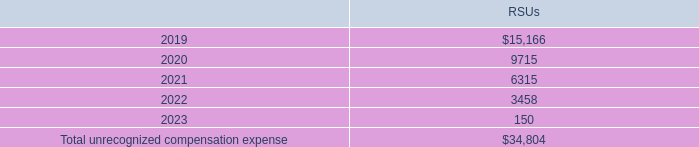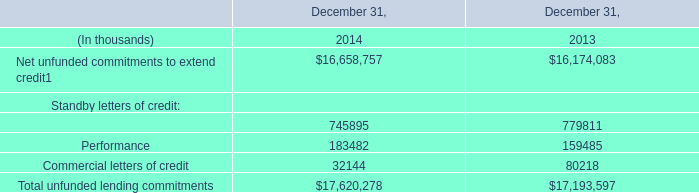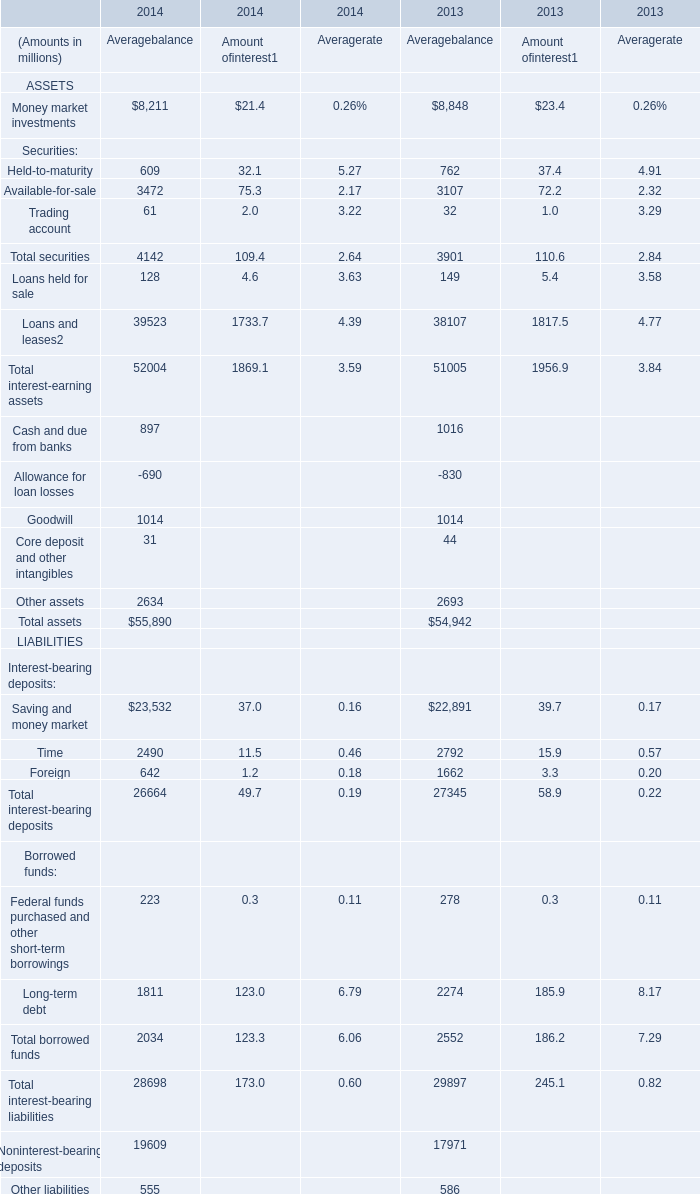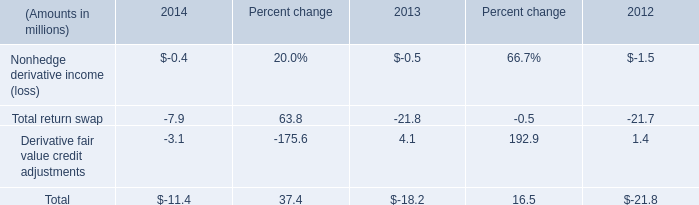What's the average of the Total return swap for amount in the years where Financial for Standby letters of credit is positive? (in million) 
Computations: ((-7.9 - 21.8) / 2)
Answer: -14.85. 